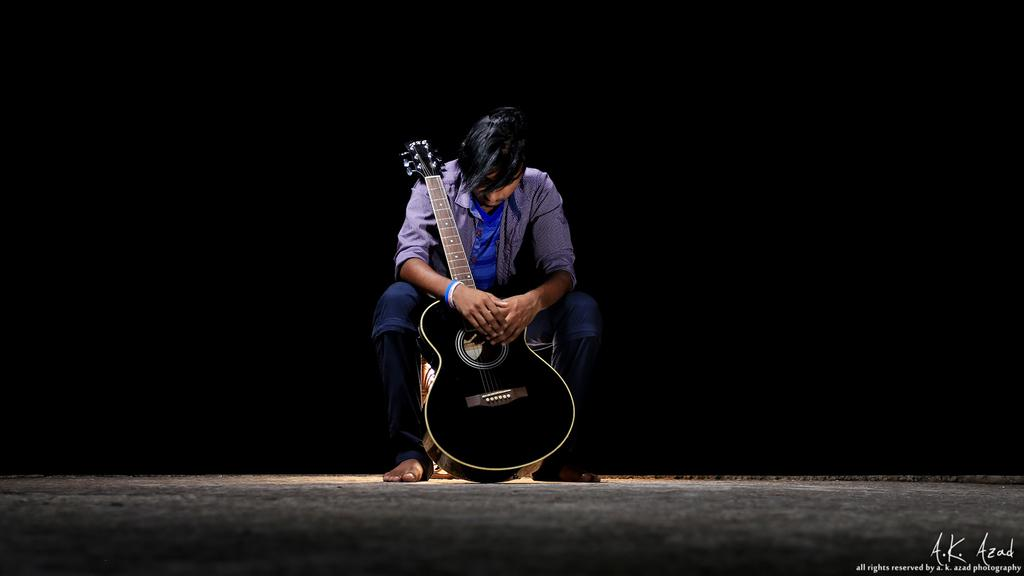What is the main subject of the image? There is a human in the image. What is the human doing in the image? The human is sitting on a table. What object is the human holding in the image? The human is holding a guitar. What type of rail can be seen in the image? There is no rail present in the image. Is the human brushing their teeth with a toothbrush in the image? There is no toothbrush or indication of teeth brushing in the image. 